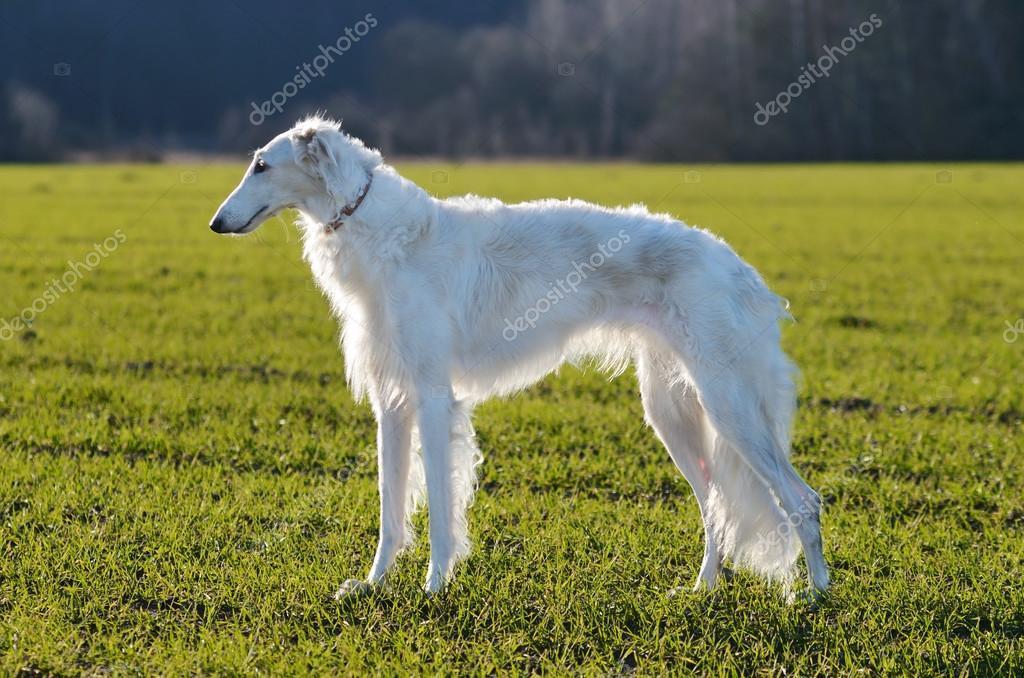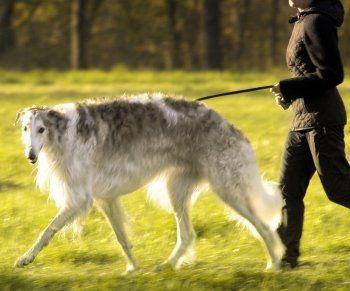The first image is the image on the left, the second image is the image on the right. For the images shown, is this caption "One dog is with a handler and one is not." true? Answer yes or no. Yes. 